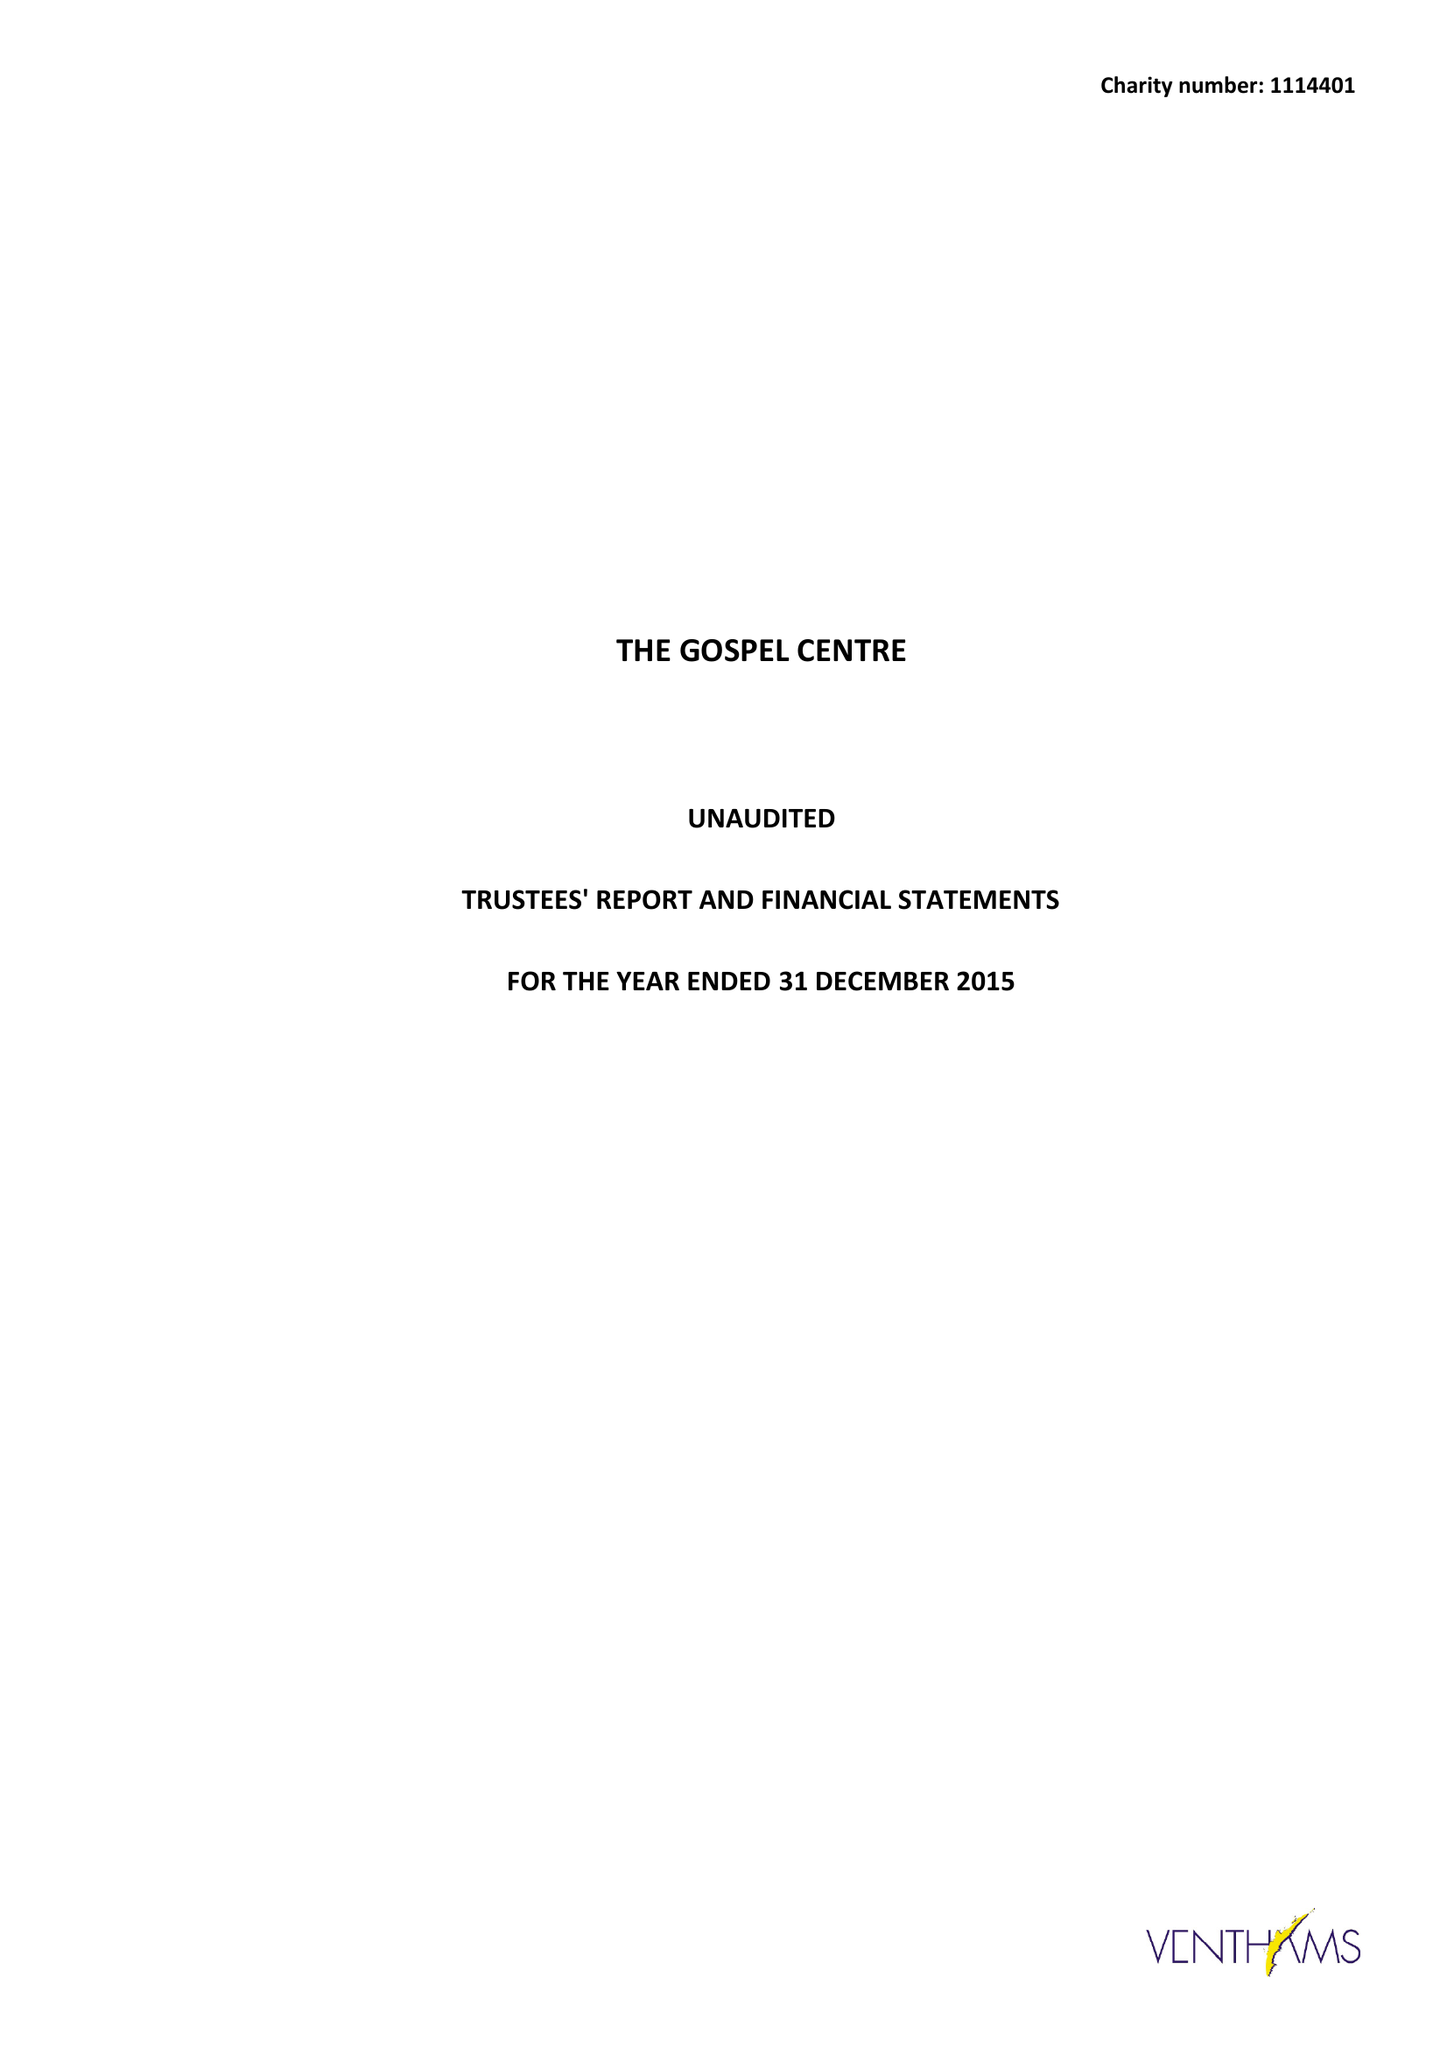What is the value for the address__postcode?
Answer the question using a single word or phrase. N8 0LT 